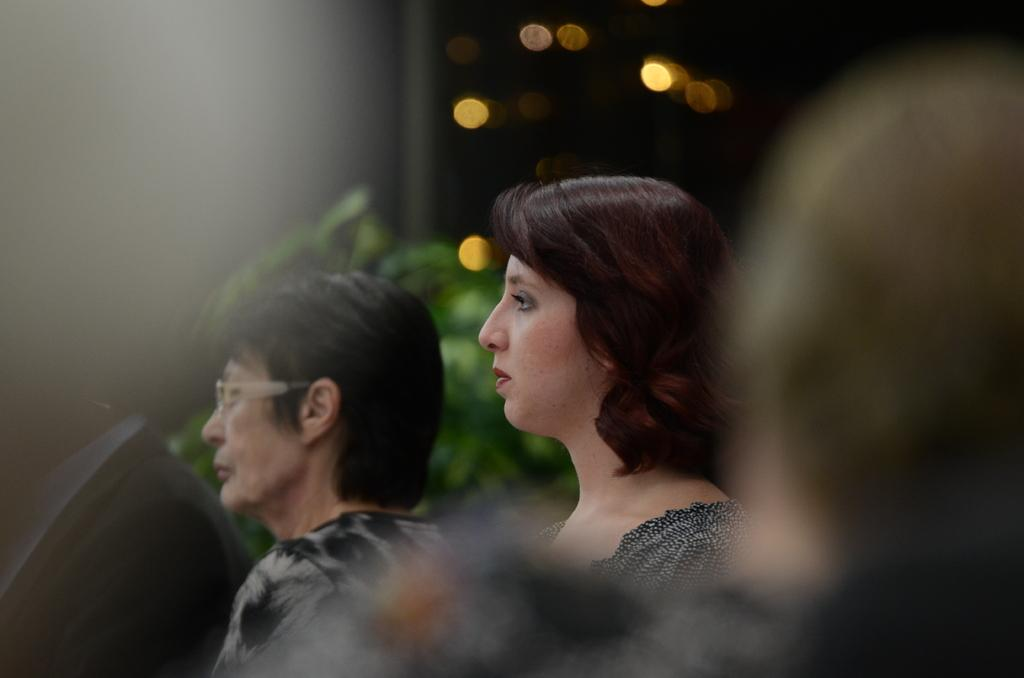What is present in the image? There are people in the image. What can be seen in the background of the image? There are plants and lights in the background of the image. What type of faucet can be seen in the image? There is no faucet present in the image. What kind of apparel are the people wearing in the image? The provided facts do not mention any specific apparel worn by the people in the image. How does the image convey respect? The image itself does not convey respect; it is a visual representation of people and background elements. 